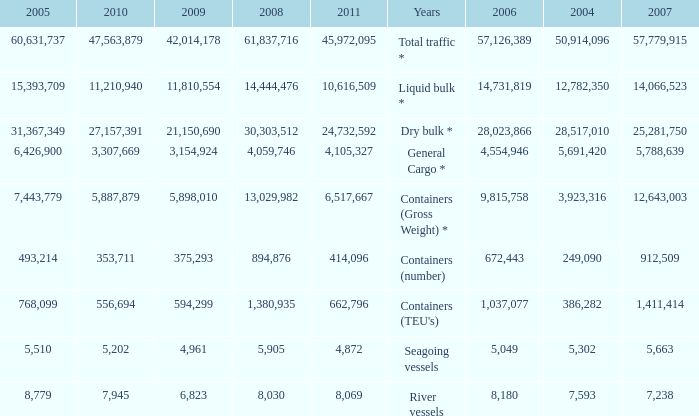What was the average value in 2005 when 2008 is 61,837,716, and a 2006 is more than 57,126,389? None. 